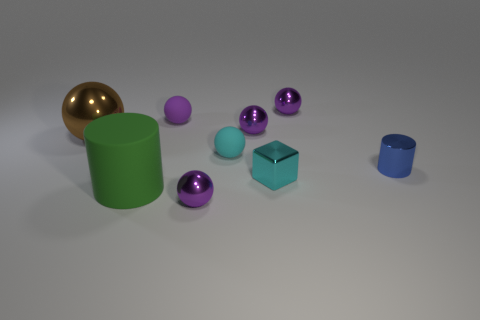Are there an equal number of purple metallic spheres in front of the big metal sphere and small green shiny cylinders?
Offer a terse response. No. Is the shape of the cyan thing in front of the small cyan rubber thing the same as  the big green rubber thing?
Provide a short and direct response. No. The big brown object has what shape?
Your answer should be compact. Sphere. The purple ball that is in front of the metallic ball left of the metal sphere in front of the small blue shiny cylinder is made of what material?
Make the answer very short. Metal. There is a sphere that is the same color as the small block; what is its material?
Keep it short and to the point. Rubber. What number of things are yellow blocks or blocks?
Provide a short and direct response. 1. Does the ball in front of the big green matte object have the same material as the small blue cylinder?
Provide a short and direct response. Yes. What number of objects are either spheres that are in front of the small cyan matte sphere or tiny matte things?
Keep it short and to the point. 3. What color is the large sphere that is the same material as the block?
Ensure brevity in your answer.  Brown. Is there a purple object that has the same size as the matte cylinder?
Provide a short and direct response. No. 